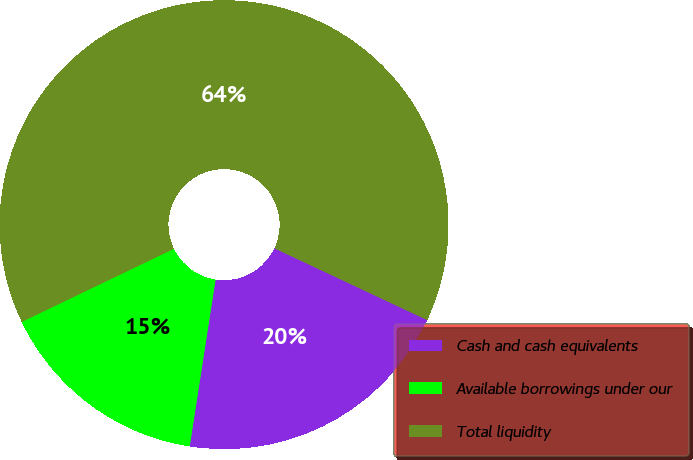Convert chart to OTSL. <chart><loc_0><loc_0><loc_500><loc_500><pie_chart><fcel>Cash and cash equivalents<fcel>Available borrowings under our<fcel>Total liquidity<nl><fcel>20.46%<fcel>15.42%<fcel>64.12%<nl></chart> 